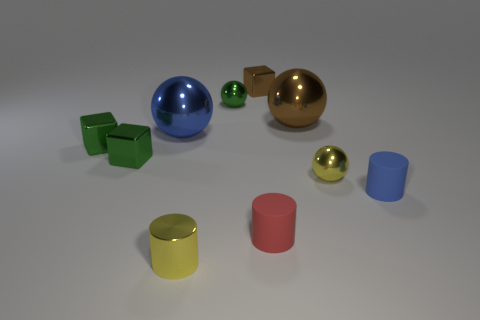What time of day does the lighting in the image suggest? The lighting in the image appears to be neutral and diffused, suggesting an indoor environment with artificial lighting rather than natural outdoor lighting. There are no discernible shadows or highlights that would indicate a particular time of day. Do the shadows tell us anything about the light source? Yes, the shadows are soft and not very pronounced, which signifies that the light source is either large or diffused, possibly situated above the objects. This is typical of a studio lighting setup designed to minimize harsh shadows. 